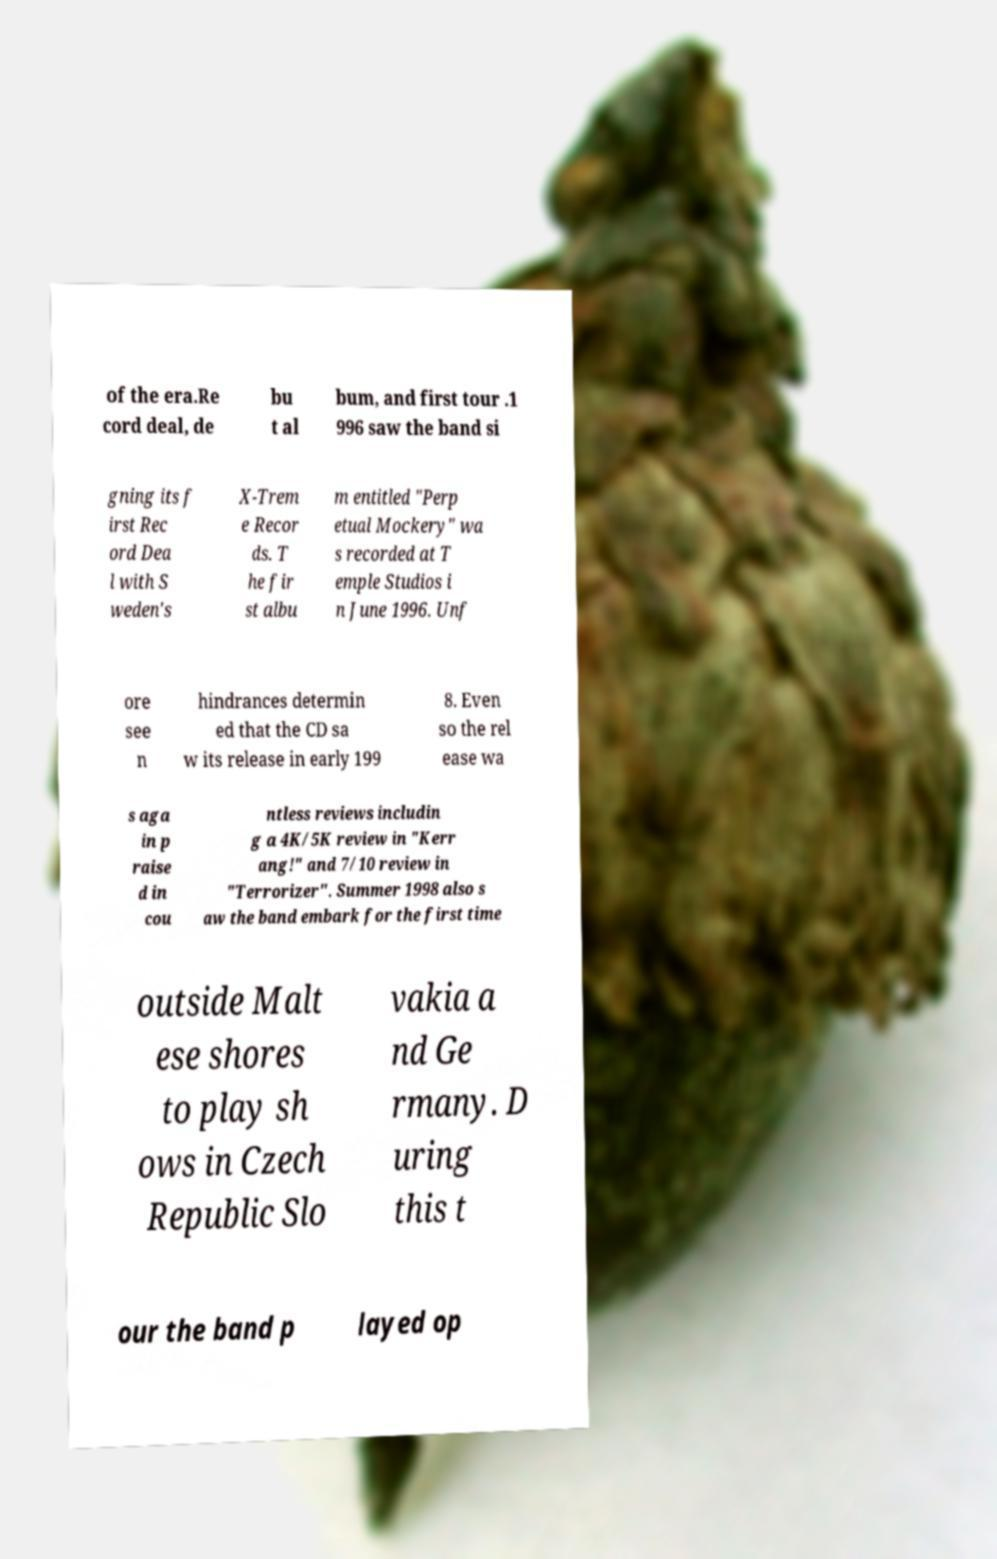There's text embedded in this image that I need extracted. Can you transcribe it verbatim? of the era.Re cord deal, de bu t al bum, and first tour .1 996 saw the band si gning its f irst Rec ord Dea l with S weden's X-Trem e Recor ds. T he fir st albu m entitled "Perp etual Mockery" wa s recorded at T emple Studios i n June 1996. Unf ore see n hindrances determin ed that the CD sa w its release in early 199 8. Even so the rel ease wa s aga in p raise d in cou ntless reviews includin g a 4K/5K review in "Kerr ang!" and 7/10 review in "Terrorizer". Summer 1998 also s aw the band embark for the first time outside Malt ese shores to play sh ows in Czech Republic Slo vakia a nd Ge rmany. D uring this t our the band p layed op 